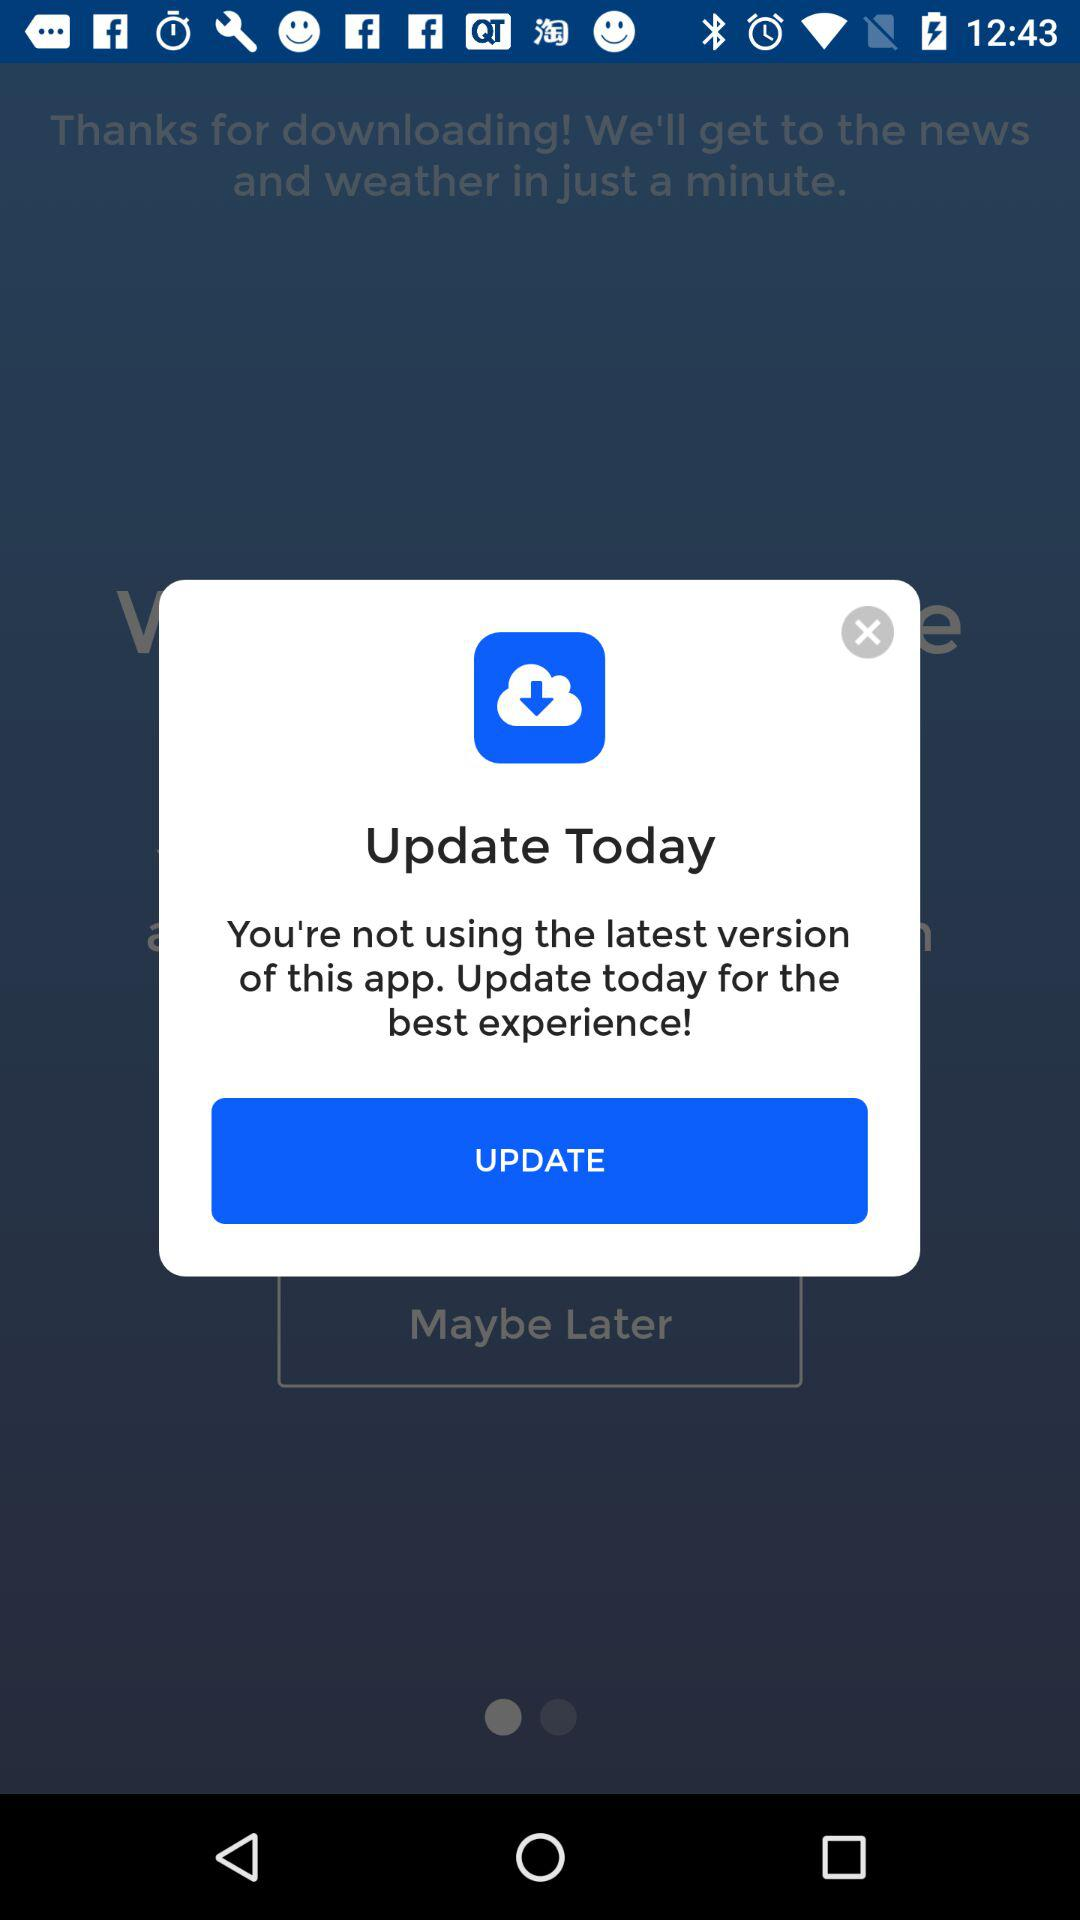What do we need to do for the best experience? For the best experience, you need to update today. 